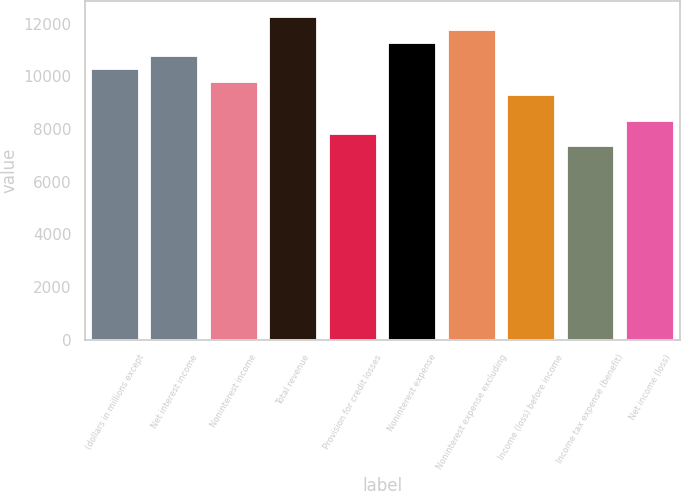<chart> <loc_0><loc_0><loc_500><loc_500><bar_chart><fcel>(dollars in millions except<fcel>Net interest income<fcel>Noninterest income<fcel>Total revenue<fcel>Provision for credit losses<fcel>Noninterest expense<fcel>Noninterest expense excluding<fcel>Income (loss) before income<fcel>Income tax expense (benefit)<fcel>Net income (loss)<nl><fcel>10276.9<fcel>10766.2<fcel>9787.5<fcel>12234.2<fcel>7830.1<fcel>11255.5<fcel>11744.9<fcel>9298.15<fcel>7340.75<fcel>8319.45<nl></chart> 